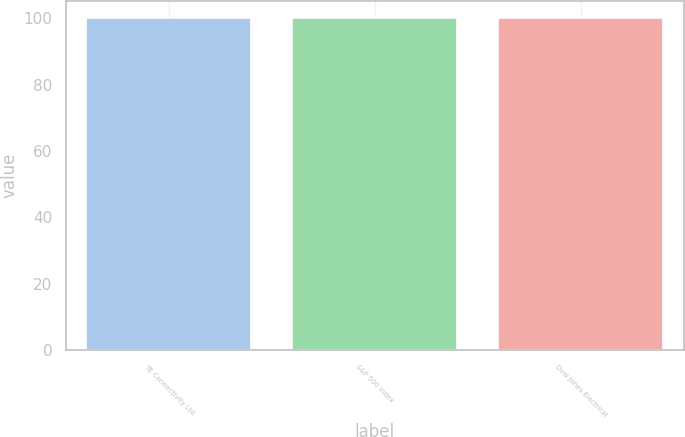Convert chart to OTSL. <chart><loc_0><loc_0><loc_500><loc_500><bar_chart><fcel>TE Connectivity Ltd<fcel>S&P 500 Index<fcel>Dow Jones Electrical<nl><fcel>100<fcel>100.1<fcel>100.2<nl></chart> 